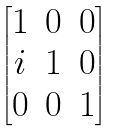Convert formula to latex. <formula><loc_0><loc_0><loc_500><loc_500>\begin{bmatrix} 1 & 0 & 0 \\ i & 1 & 0 \\ 0 & 0 & 1 \end{bmatrix}</formula> 